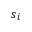<formula> <loc_0><loc_0><loc_500><loc_500>s _ { i }</formula> 